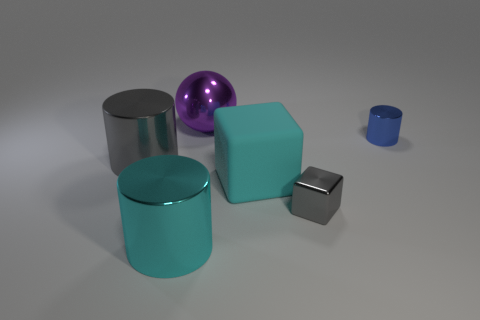How many purple objects are either shiny cylinders or large metal spheres?
Your answer should be compact. 1. What is the big thing that is both in front of the tiny shiny cylinder and right of the cyan shiny thing made of?
Ensure brevity in your answer.  Rubber. Is the small gray object made of the same material as the big cyan block?
Give a very brief answer. No. What number of cyan blocks are the same size as the blue object?
Your answer should be compact. 0. Is the number of cyan metal cylinders that are to the right of the cyan matte cube the same as the number of large red spheres?
Your response must be concise. Yes. What number of things are both left of the cyan cube and in front of the tiny blue object?
Offer a terse response. 2. There is a large metallic object that is in front of the small metal block; does it have the same shape as the big gray metallic thing?
Your response must be concise. Yes. What is the material of the cyan object that is the same size as the cyan cylinder?
Offer a terse response. Rubber. Are there the same number of tiny gray objects that are on the left side of the gray cylinder and big cyan metal cylinders that are in front of the purple metallic thing?
Ensure brevity in your answer.  No. What number of blocks are behind the gray thing that is to the left of the large shiny ball that is behind the big matte thing?
Your response must be concise. 0. 